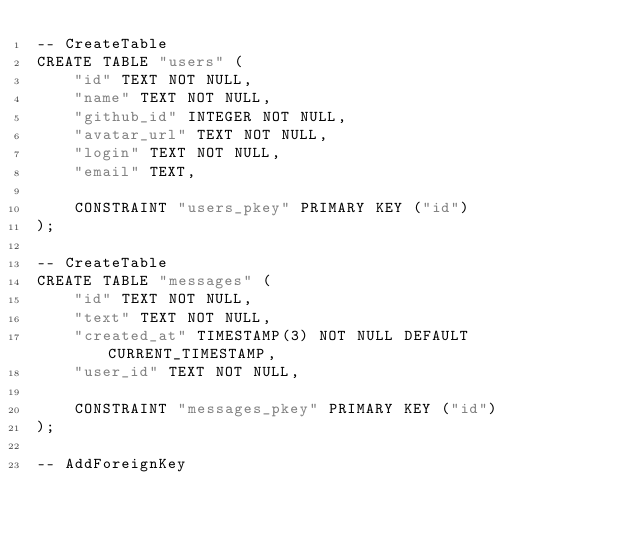Convert code to text. <code><loc_0><loc_0><loc_500><loc_500><_SQL_>-- CreateTable
CREATE TABLE "users" (
    "id" TEXT NOT NULL,
    "name" TEXT NOT NULL,
    "github_id" INTEGER NOT NULL,
    "avatar_url" TEXT NOT NULL,
    "login" TEXT NOT NULL,
    "email" TEXT,

    CONSTRAINT "users_pkey" PRIMARY KEY ("id")
);

-- CreateTable
CREATE TABLE "messages" (
    "id" TEXT NOT NULL,
    "text" TEXT NOT NULL,
    "created_at" TIMESTAMP(3) NOT NULL DEFAULT CURRENT_TIMESTAMP,
    "user_id" TEXT NOT NULL,

    CONSTRAINT "messages_pkey" PRIMARY KEY ("id")
);

-- AddForeignKey</code> 